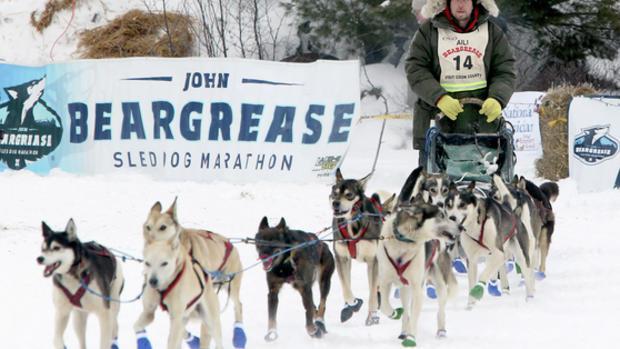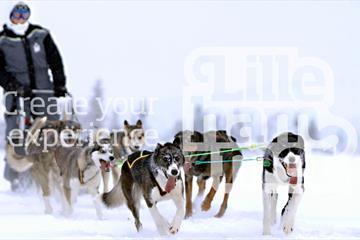The first image is the image on the left, the second image is the image on the right. For the images shown, is this caption "The dog sled teams in the left and right images are moving forward and are angled so they head toward each other." true? Answer yes or no. No. The first image is the image on the left, the second image is the image on the right. Given the left and right images, does the statement "One of the images features two people riding a single sled." hold true? Answer yes or no. No. 